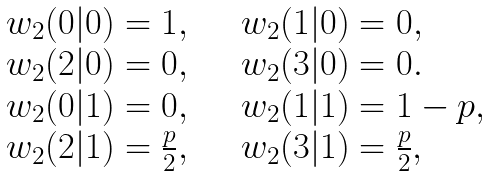<formula> <loc_0><loc_0><loc_500><loc_500>\begin{array} { l l } w _ { 2 } ( 0 | 0 ) = 1 , & \quad w _ { 2 } ( 1 | 0 ) = 0 , \\ w _ { 2 } ( 2 | 0 ) = 0 , & \quad w _ { 2 } ( 3 | 0 ) = 0 . \\ w _ { 2 } ( 0 | 1 ) = 0 , & \quad w _ { 2 } ( 1 | 1 ) = 1 - p , \\ w _ { 2 } ( 2 | 1 ) = \frac { p } { 2 } , & \quad w _ { 2 } ( 3 | 1 ) = \frac { p } { 2 } , \end{array}</formula> 